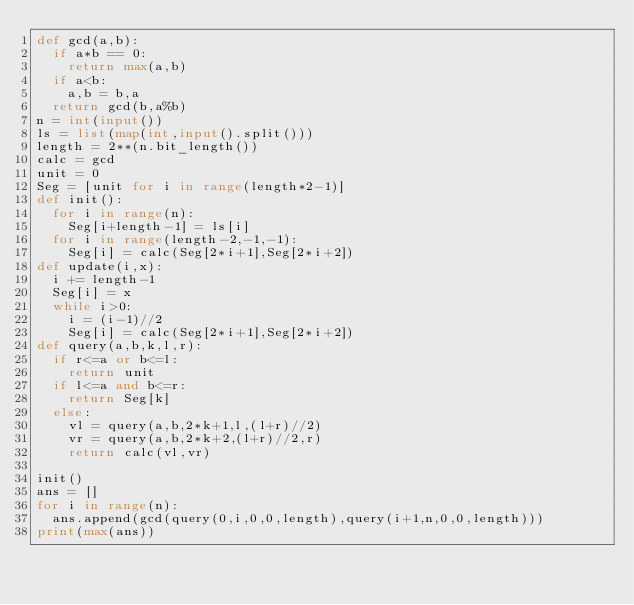Convert code to text. <code><loc_0><loc_0><loc_500><loc_500><_Python_>def gcd(a,b):
  if a*b == 0:
    return max(a,b)
  if a<b:
    a,b = b,a
  return gcd(b,a%b)
n = int(input())
ls = list(map(int,input().split()))
length = 2**(n.bit_length())
calc = gcd
unit = 0
Seg = [unit for i in range(length*2-1)]
def init():
  for i in range(n):
    Seg[i+length-1] = ls[i]
  for i in range(length-2,-1,-1):
    Seg[i] = calc(Seg[2*i+1],Seg[2*i+2])
def update(i,x):
  i += length-1
  Seg[i] = x
  while i>0:
    i = (i-1)//2
    Seg[i] = calc(Seg[2*i+1],Seg[2*i+2])
def query(a,b,k,l,r):
  if r<=a or b<=l:
    return unit
  if l<=a and b<=r:
    return Seg[k]
  else:
    vl = query(a,b,2*k+1,l,(l+r)//2)
    vr = query(a,b,2*k+2,(l+r)//2,r)
    return calc(vl,vr)

init()
ans = []
for i in range(n):
  ans.append(gcd(query(0,i,0,0,length),query(i+1,n,0,0,length)))
print(max(ans))</code> 